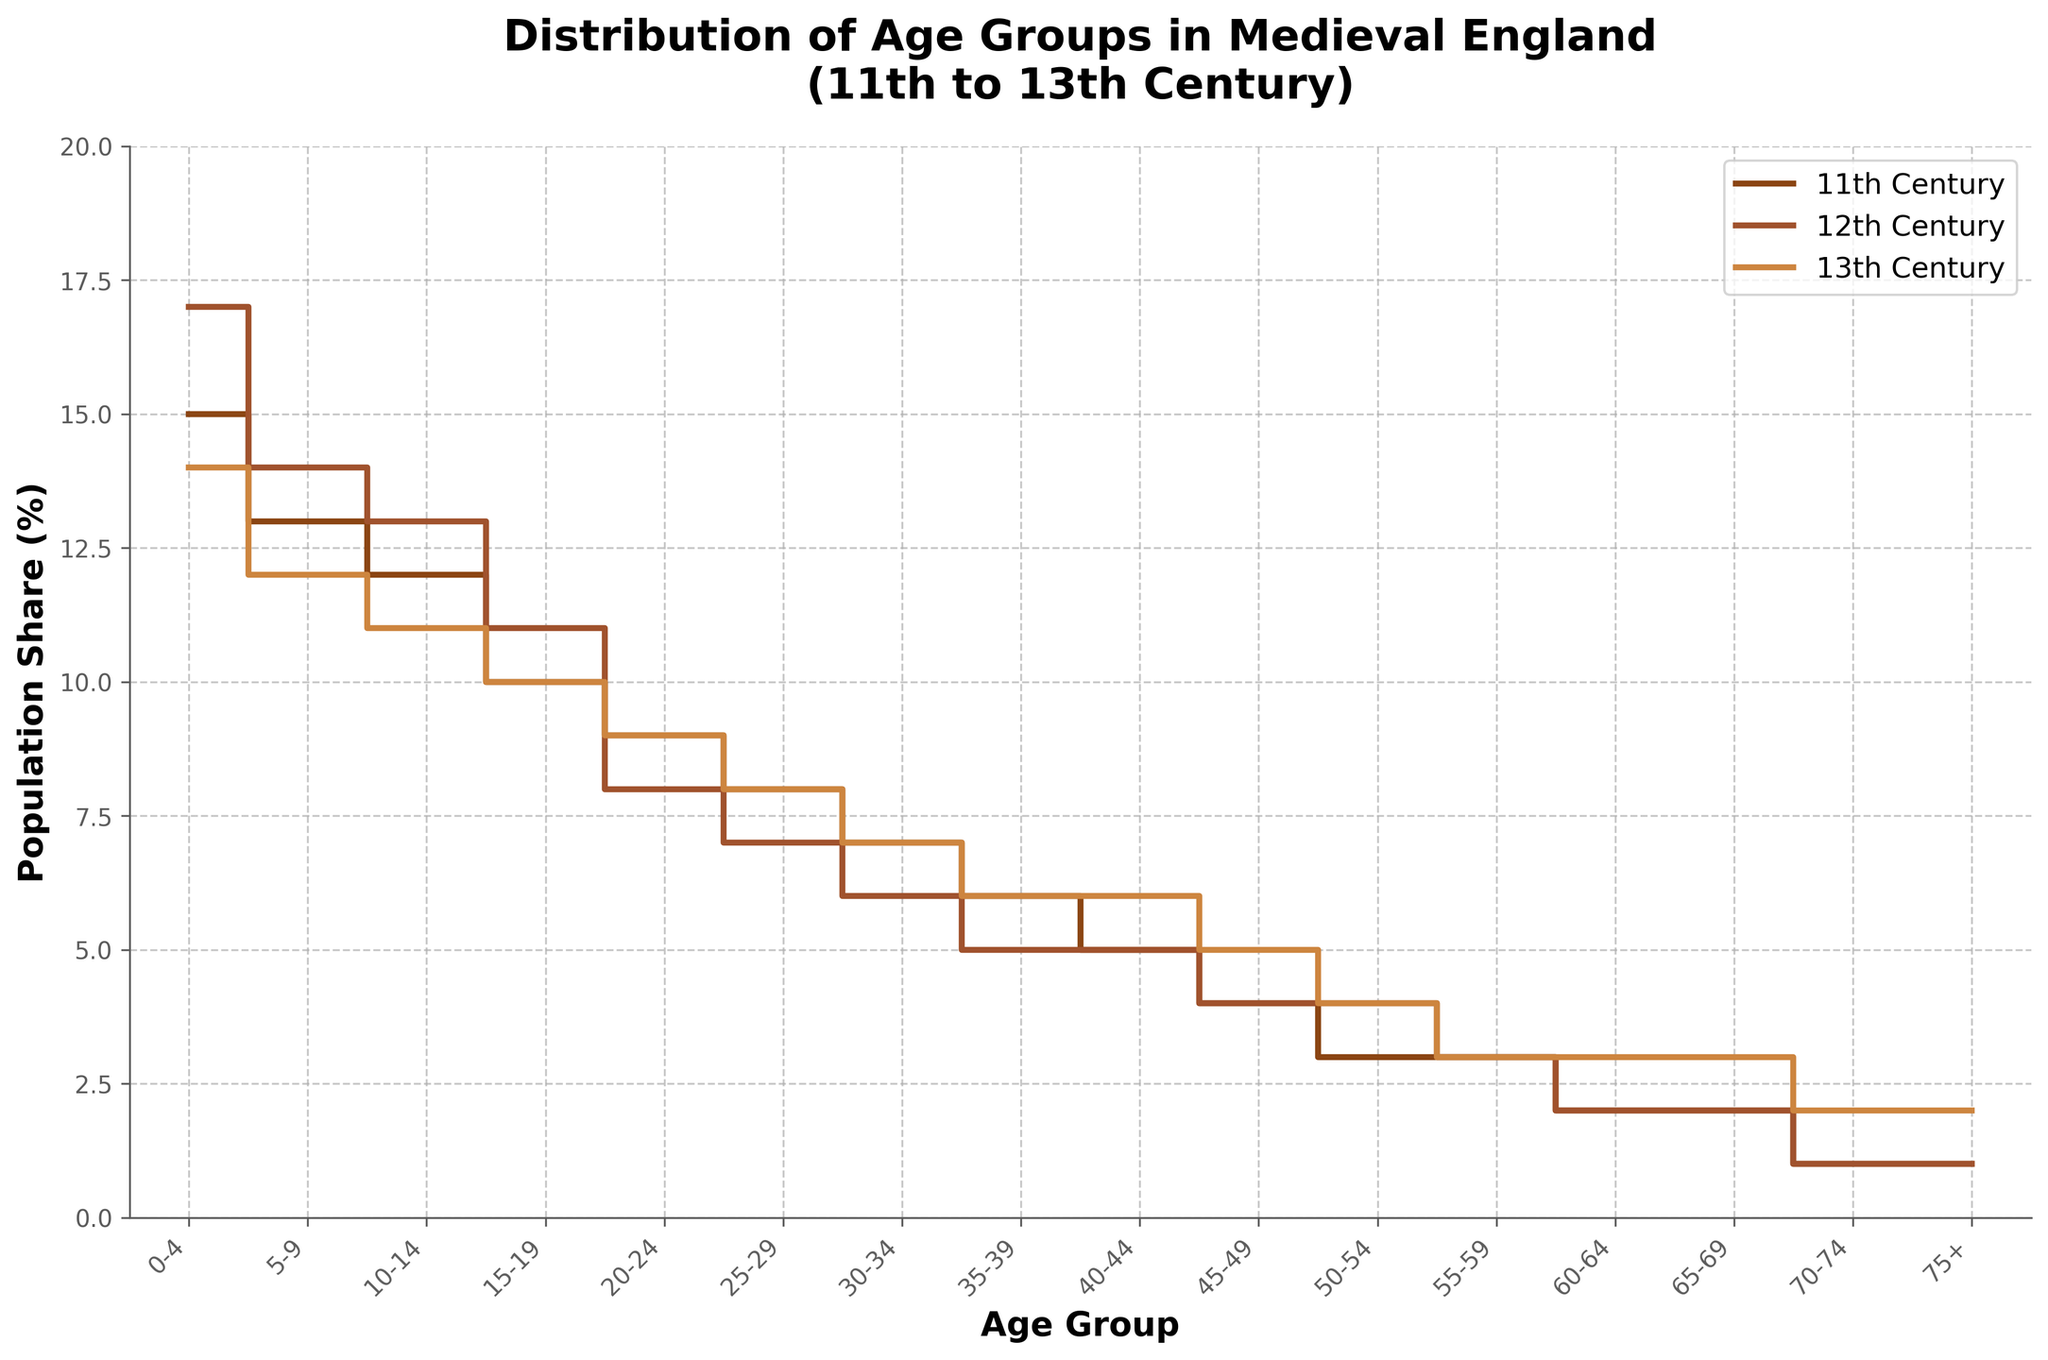What's the title of the figure? Look at the top of the figure where the title is usually placed.
Answer: Distribution of Age Groups in Medieval England (11th to 13th Century) Which age group has the highest population share in the 11th century? Identify the highest step on the plot for the 11th century data (brown line), then trace it back to the corresponding age group.
Answer: 0-4 How did the population share of the 30-34 age group change from the 11th to the 13th century? Compare the population share of the 30-34 age group in the 11th century to its value in the 13th century. Look at the brown line for the 11th century and the tan line for the 13th century.
Answer: Unchanged Which century had the most consistent population share across all age groups? Look at the lines for each century and identify which one is the most horizontal, indicating the least variation.
Answer: 13th Century What's the combined population share of the age groups 50-54 and 55-59 in the 12th century? Find the population share for each of these age groups in the 12th century (middle line) and add them together.
Answer: 7% In the 13th century, which age group has a higher population share: 60-64 or 65-69? Locate the points on the tan line representing these age groups and compare their heights.
Answer: 65-69 Describe the trend in population share for the age group 15-19 from the 11th to the 13th century. Trace the population share for the 15-19 age group across the three lines, observing the change.
Answer: Decreasing What's the population share difference between the 75+ age group and the 0-4 age group in the 13th century? Find the population shares for these age groups in the 13th century and calculate their difference (14% - 2%).
Answer: 12% Which age group saw an increase in population share from the 11th to the 13th century but remained stable in the 12th century? Identify the age groups with increasing share from the 11th (brown line) to the 13th century (tan line) and look for stability across the 12th century (middle line).
Answer: 75+ In which century did the age group 10-14 have its lowest population share? Compare the population shares for the 10-14 age group across all three centuries and identify the lowest value.
Answer: 13th Century 